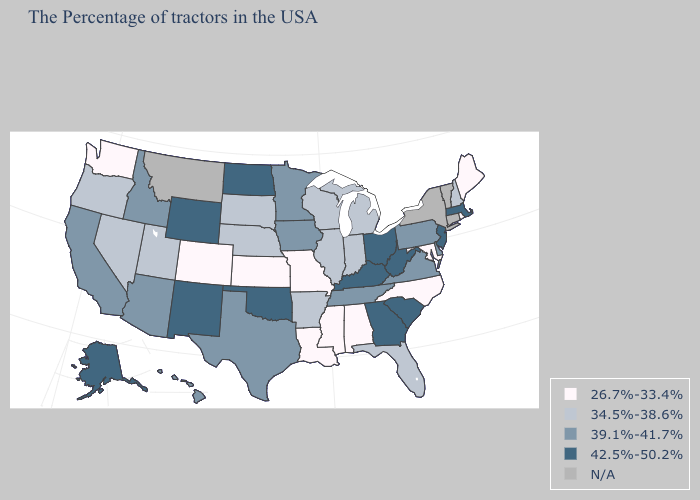What is the lowest value in the South?
Answer briefly. 26.7%-33.4%. Name the states that have a value in the range 42.5%-50.2%?
Be succinct. Massachusetts, New Jersey, South Carolina, West Virginia, Ohio, Georgia, Kentucky, Oklahoma, North Dakota, Wyoming, New Mexico, Alaska. Does Washington have the lowest value in the West?
Keep it brief. Yes. Among the states that border New York , does Pennsylvania have the highest value?
Concise answer only. No. Name the states that have a value in the range 42.5%-50.2%?
Quick response, please. Massachusetts, New Jersey, South Carolina, West Virginia, Ohio, Georgia, Kentucky, Oklahoma, North Dakota, Wyoming, New Mexico, Alaska. What is the value of West Virginia?
Quick response, please. 42.5%-50.2%. Among the states that border Nebraska , which have the highest value?
Give a very brief answer. Wyoming. Name the states that have a value in the range 39.1%-41.7%?
Keep it brief. Delaware, Pennsylvania, Virginia, Tennessee, Minnesota, Iowa, Texas, Arizona, Idaho, California, Hawaii. Is the legend a continuous bar?
Answer briefly. No. Name the states that have a value in the range 26.7%-33.4%?
Keep it brief. Maine, Rhode Island, Maryland, North Carolina, Alabama, Mississippi, Louisiana, Missouri, Kansas, Colorado, Washington. What is the lowest value in states that border Iowa?
Keep it brief. 26.7%-33.4%. What is the highest value in states that border Michigan?
Answer briefly. 42.5%-50.2%. What is the value of Vermont?
Concise answer only. N/A. Name the states that have a value in the range 34.5%-38.6%?
Write a very short answer. New Hampshire, Florida, Michigan, Indiana, Wisconsin, Illinois, Arkansas, Nebraska, South Dakota, Utah, Nevada, Oregon. Among the states that border Tennessee , which have the lowest value?
Answer briefly. North Carolina, Alabama, Mississippi, Missouri. 